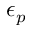Convert formula to latex. <formula><loc_0><loc_0><loc_500><loc_500>\epsilon _ { p }</formula> 